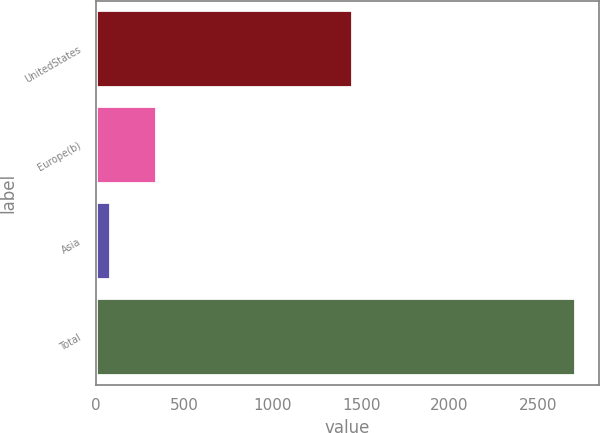Convert chart. <chart><loc_0><loc_0><loc_500><loc_500><bar_chart><fcel>UnitedStates<fcel>Europe(b)<fcel>Asia<fcel>Total<nl><fcel>1446<fcel>343.1<fcel>80<fcel>2711<nl></chart> 